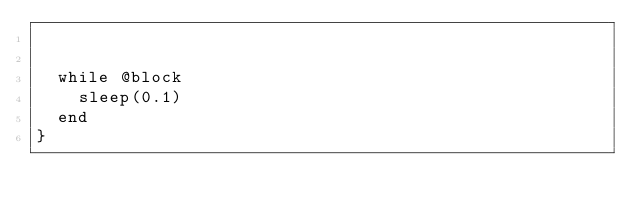<code> <loc_0><loc_0><loc_500><loc_500><_Ruby_>

  while @block
    sleep(0.1)
  end
}
</code> 